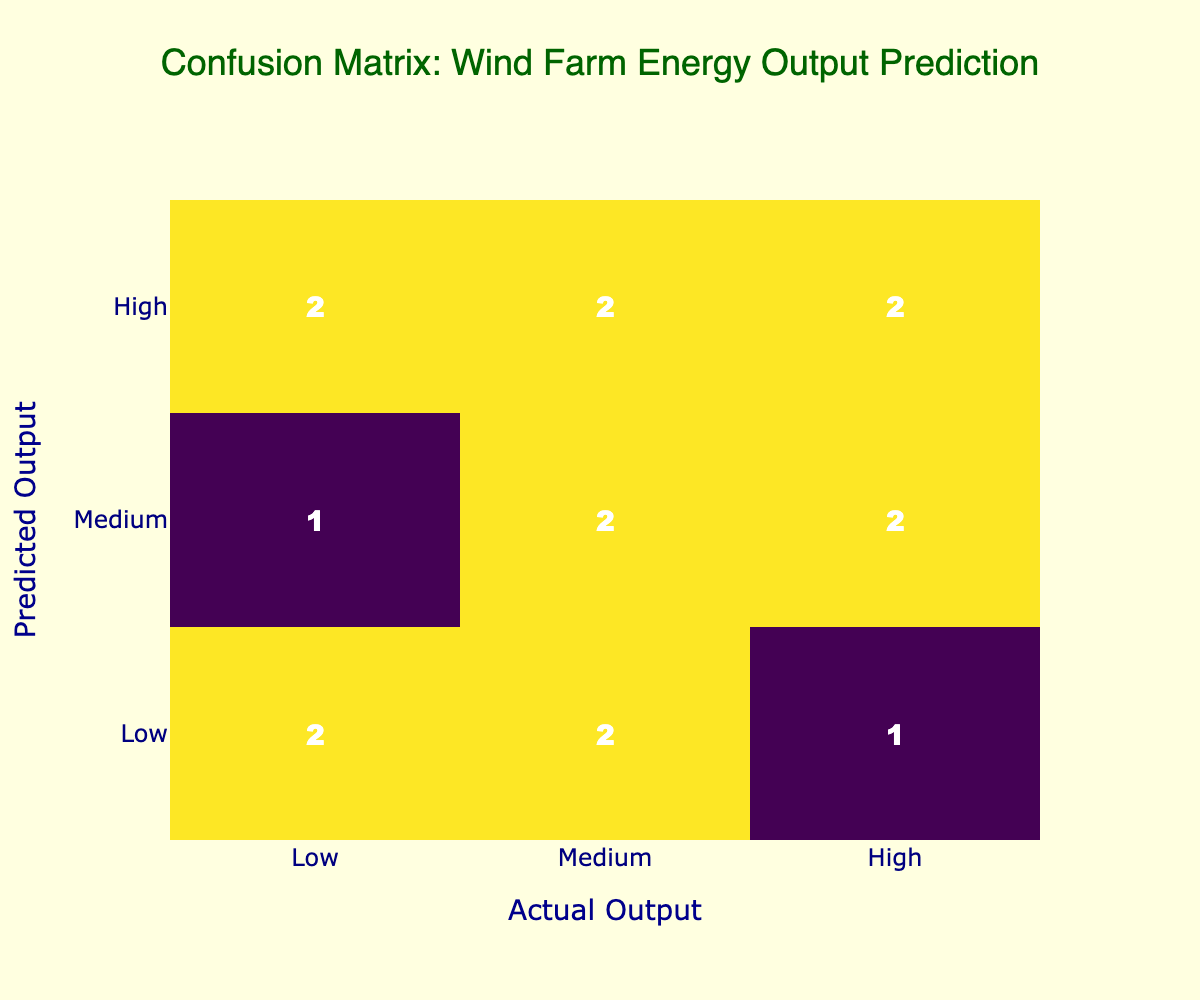What is the number of instances where the predicted output is High and the actual output is High? From the confusion matrix, we can look at the cell where the predicted output is "High" and the actual output is also "High". There are 2 instances in this cell.
Answer: 2 What is the total number of predictions made in the category of Medium? To find this, we need to add the predicted outputs when the actual output was either High, Medium, or Low. The numbers in the Medium row are: 1 (High), 3 (Medium), and 1 (Low). So, total = 1 + 3 + 1 = 5.
Answer: 5 Is there any instance where the predicted output is Low and the actual output is High? Checking the confusion matrix, we can see the cell where the predicted output is "Low" and the actual output is "High" contains a value of 1. Therefore, there is 1 such instance.
Answer: Yes What is the total count of correct predictions made? Correct predictions occur where the predicted output matches the actual output. The diagonal of the confusion matrix shows correct predictions: High-High (2), Medium-Medium (3), Low-Low (3). Thus, Total Correct = 2 + 3 + 3 = 8.
Answer: 8 What is the percentage of total predictions that were correct? The total predictions can be calculated by summing all the cells in the confusion matrix, which is 15. The total correct predictions, from the previous question, is 8. Therefore, the percentage = (8/15) * 100 ≈ 53.33%.
Answer: Approximately 53.33% 